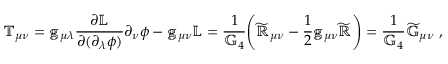Convert formula to latex. <formula><loc_0><loc_0><loc_500><loc_500>\mathbb { T } _ { \mu \nu } = \mathbb { g } _ { \mu \lambda } \frac { \partial \mathbb { L } } { \partial ( \partial _ { \lambda } \phi ) } \partial _ { \nu } \phi - \mathbb { g } _ { \mu \nu } \mathbb { L } = \frac { 1 } { \mathbb { G } _ { 4 } } \left ( \mathbb { \widetilde { R } } _ { \mu \nu } - \frac { 1 } { 2 } \mathbb { g } _ { \mu \nu } \mathbb { \widetilde { R } } \right ) = \frac { 1 } { \mathbb { G } _ { 4 } } \mathbb { \widetilde { G } } _ { \mu \nu } ,</formula> 